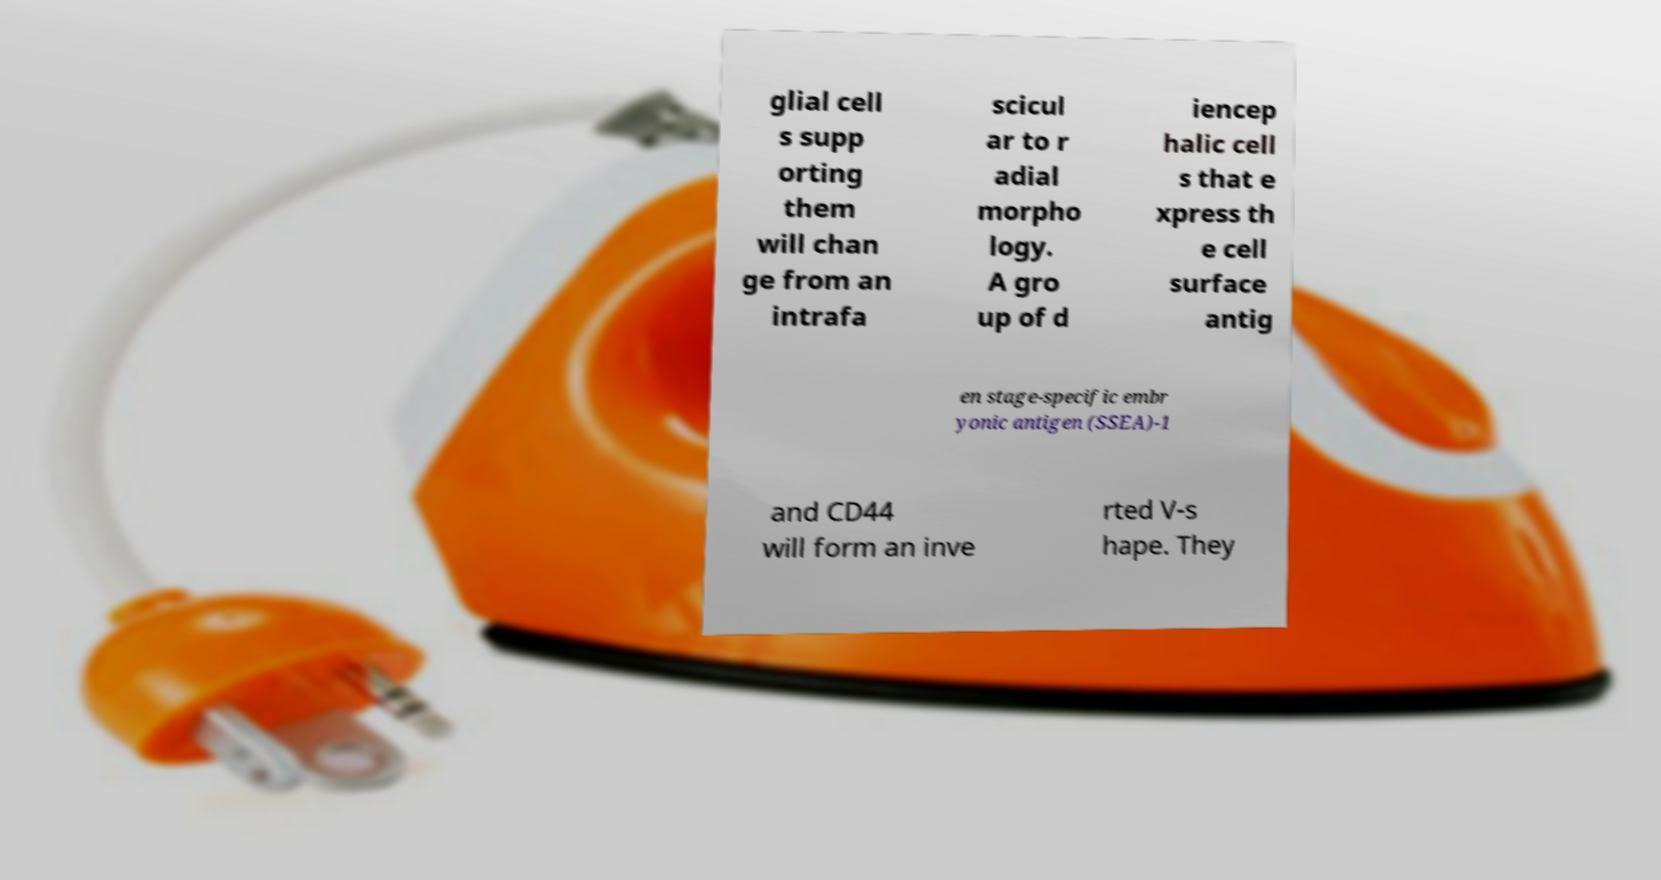What messages or text are displayed in this image? I need them in a readable, typed format. glial cell s supp orting them will chan ge from an intrafa scicul ar to r adial morpho logy. A gro up of d iencep halic cell s that e xpress th e cell surface antig en stage-specific embr yonic antigen (SSEA)-1 and CD44 will form an inve rted V-s hape. They 